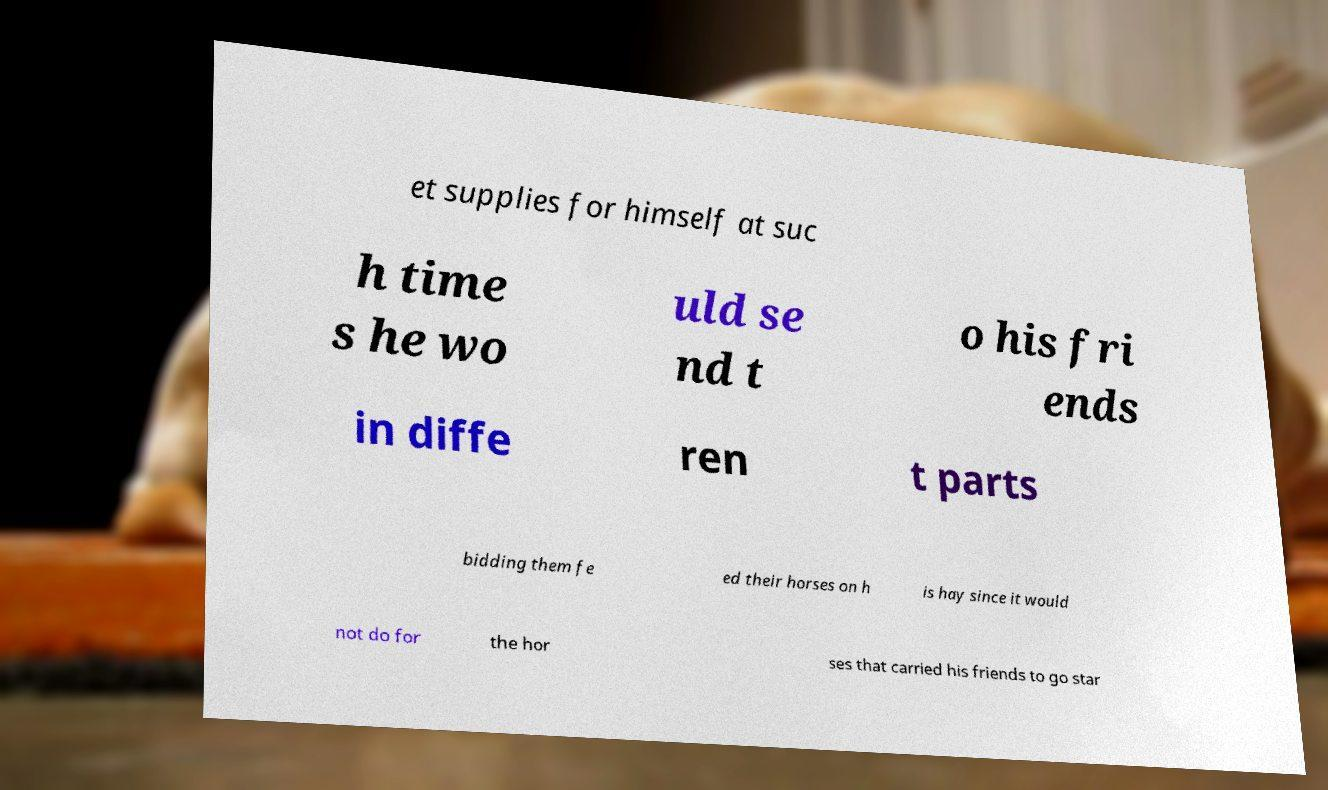Please read and relay the text visible in this image. What does it say? et supplies for himself at suc h time s he wo uld se nd t o his fri ends in diffe ren t parts bidding them fe ed their horses on h is hay since it would not do for the hor ses that carried his friends to go star 